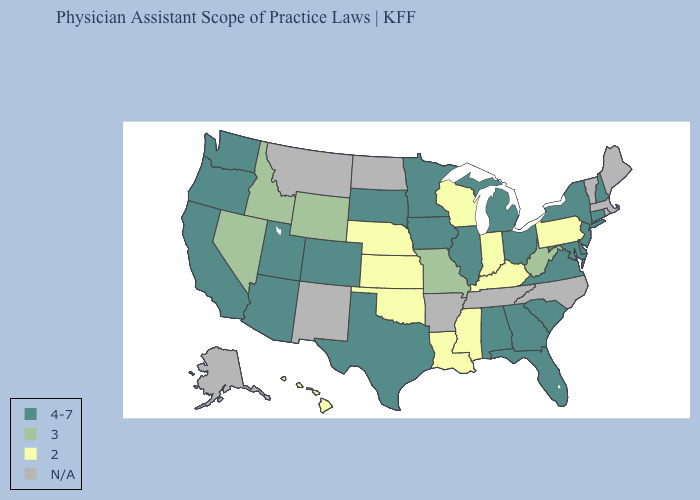Name the states that have a value in the range N/A?
Concise answer only. Alaska, Arkansas, Maine, Massachusetts, Montana, New Mexico, North Carolina, North Dakota, Rhode Island, Tennessee, Vermont. What is the lowest value in the USA?
Answer briefly. 2. Which states have the highest value in the USA?
Quick response, please. Alabama, Arizona, California, Colorado, Connecticut, Delaware, Florida, Georgia, Illinois, Iowa, Maryland, Michigan, Minnesota, New Hampshire, New Jersey, New York, Ohio, Oregon, South Carolina, South Dakota, Texas, Utah, Virginia, Washington. What is the lowest value in states that border Indiana?
Concise answer only. 2. What is the value of Maine?
Short answer required. N/A. What is the value of Hawaii?
Short answer required. 2. What is the lowest value in the MidWest?
Answer briefly. 2. What is the value of Alabama?
Be succinct. 4-7. What is the value of Connecticut?
Keep it brief. 4-7. What is the lowest value in the USA?
Write a very short answer. 2. What is the lowest value in the Northeast?
Concise answer only. 2. What is the lowest value in states that border North Dakota?
Keep it brief. 4-7. Which states have the lowest value in the West?
Answer briefly. Hawaii. How many symbols are there in the legend?
Be succinct. 4. 